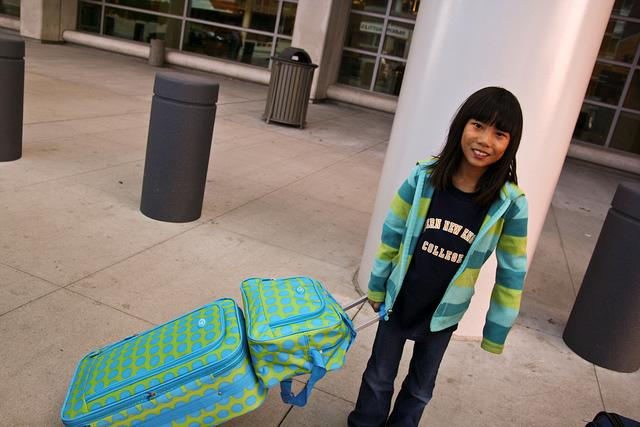Upon which vessel might this person go for a ride soon?

Choices:
A) uber
B) airplane
C) space ship
D) steamer airplane 